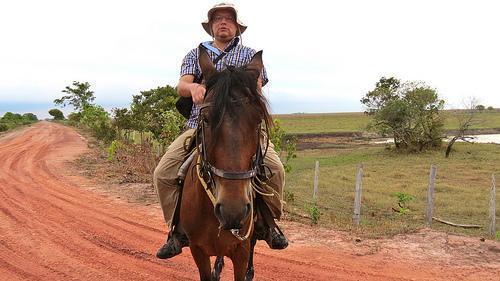How many horses are in the picture?
Give a very brief answer. 1. 